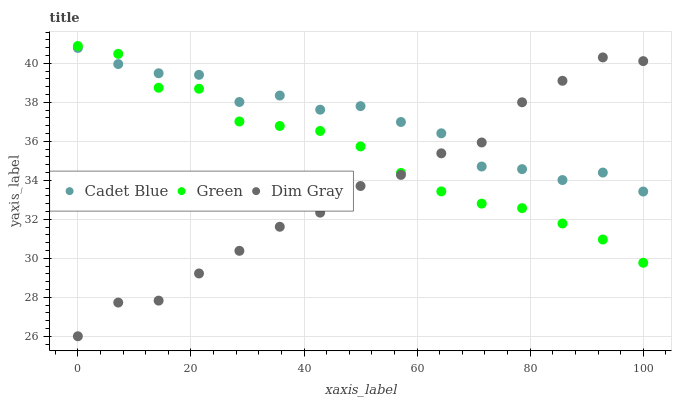Does Dim Gray have the minimum area under the curve?
Answer yes or no. Yes. Does Cadet Blue have the maximum area under the curve?
Answer yes or no. Yes. Does Green have the minimum area under the curve?
Answer yes or no. No. Does Green have the maximum area under the curve?
Answer yes or no. No. Is Green the smoothest?
Answer yes or no. Yes. Is Cadet Blue the roughest?
Answer yes or no. Yes. Is Cadet Blue the smoothest?
Answer yes or no. No. Is Green the roughest?
Answer yes or no. No. Does Dim Gray have the lowest value?
Answer yes or no. Yes. Does Green have the lowest value?
Answer yes or no. No. Does Green have the highest value?
Answer yes or no. Yes. Does Cadet Blue have the highest value?
Answer yes or no. No. Does Cadet Blue intersect Dim Gray?
Answer yes or no. Yes. Is Cadet Blue less than Dim Gray?
Answer yes or no. No. Is Cadet Blue greater than Dim Gray?
Answer yes or no. No. 